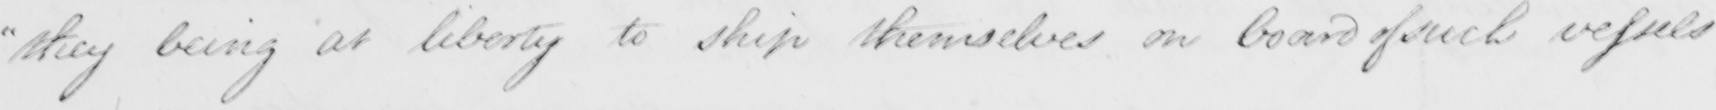Transcribe the text shown in this historical manuscript line. " they being at liberty to ship themselves on board of such vessels 